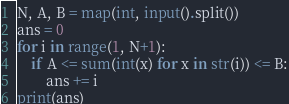Convert code to text. <code><loc_0><loc_0><loc_500><loc_500><_Python_>N, A, B = map(int, input().split())
ans = 0
for i in range(1, N+1):
    if A <= sum(int(x) for x in str(i)) <= B:
        ans += i
print(ans)</code> 